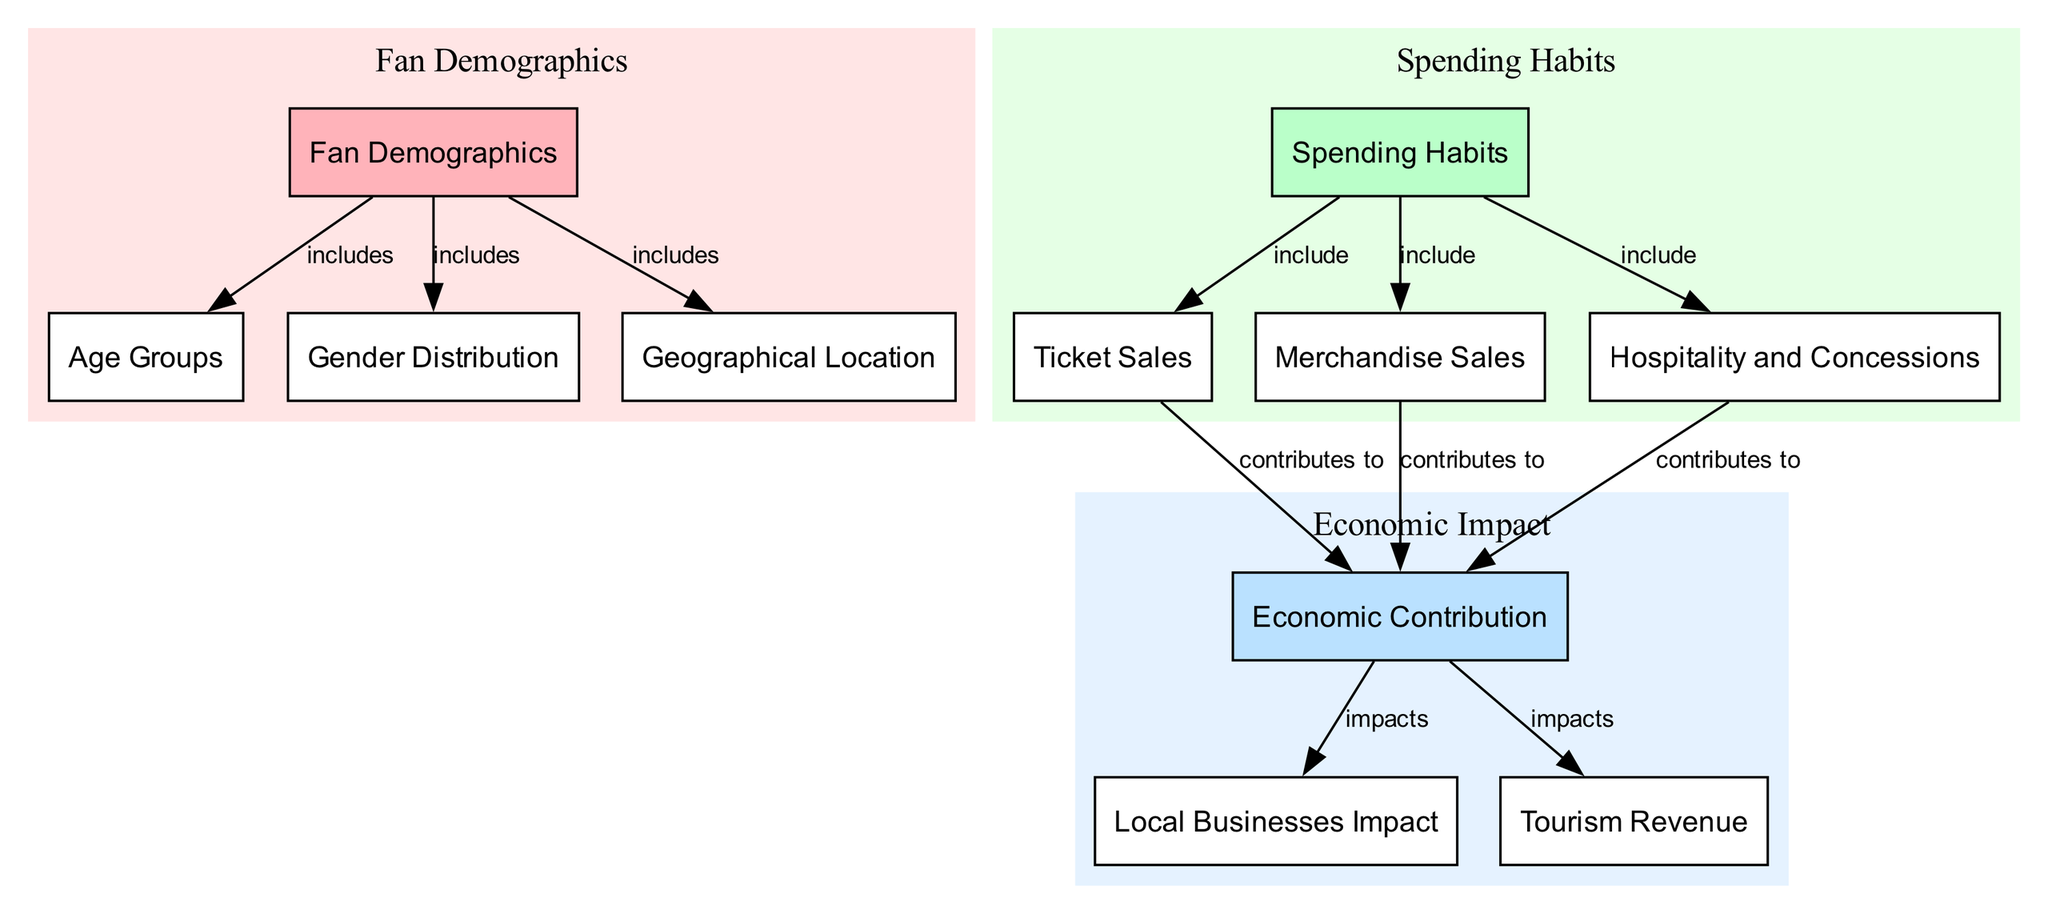What are the three main categories visualized in the diagram? The diagram focuses on three main categories: Fan Demographics, Spending Habits, and Economic Impact. These categories are represented as distinct clusters in the diagram.
Answer: Fan Demographics, Spending Habits, Economic Impact How many nodes are present in the diagram? The diagram contains a total of 11 nodes, which are the individual categories and their components. This count includes demographics, spending habits, and economic contributions insights.
Answer: 11 What does "spending_habits" include? According to the diagram, "spending_habits" includes ticket sales, merchandise sales, and hospitality. Each of these is directly connected to the spending habits node, indicating their role in what fans spend during events.
Answer: ticket sales, merchandise sales, hospitality What impacts local businesses according to the economic contribution? The diagram shows that the economic contribution impacts local businesses. This indicates a direct relationship between the overall economic impacts resulting from sporting events and the success of local businesses.
Answer: Economic Contribution Which node has the most connections in the diagram? The "economic_contribution" node has the most connections, being linked to local businesses and tourism, and also being connected to ticket sales, merchandise sales, and hospitality as contributors. This indicates its central role in the diagram.
Answer: Economic Contribution How does ticket sales contribute to the economic contribution? The diagram shows an edge labeled "contributes to" connecting ticket sales to economic contribution. This indicates that ticket sales are a source of revenue that positively impacts the broader economy based on sports events.
Answer: contributes to How many edges involve the spending habits node? The spending habits node is connected to three edges, which correspond to ticket sales, merchandise sales, and hospitality. This highlights the diverse areas where spending occurs during events.
Answer: 3 What connections does gender distribution have? Gender distribution is directly connected to fan demographics only, indicating that it is a subset of the overall demographic insights provided in the diagram.
Answer: Fan Demographics Which factors are highlighted under tourism revenue? The diagram connects tourism directly to economic contribution, suggesting that tourism revenue is an important element derived from sporting events, contributing to the economy in a significant manner.
Answer: Economic Contribution 